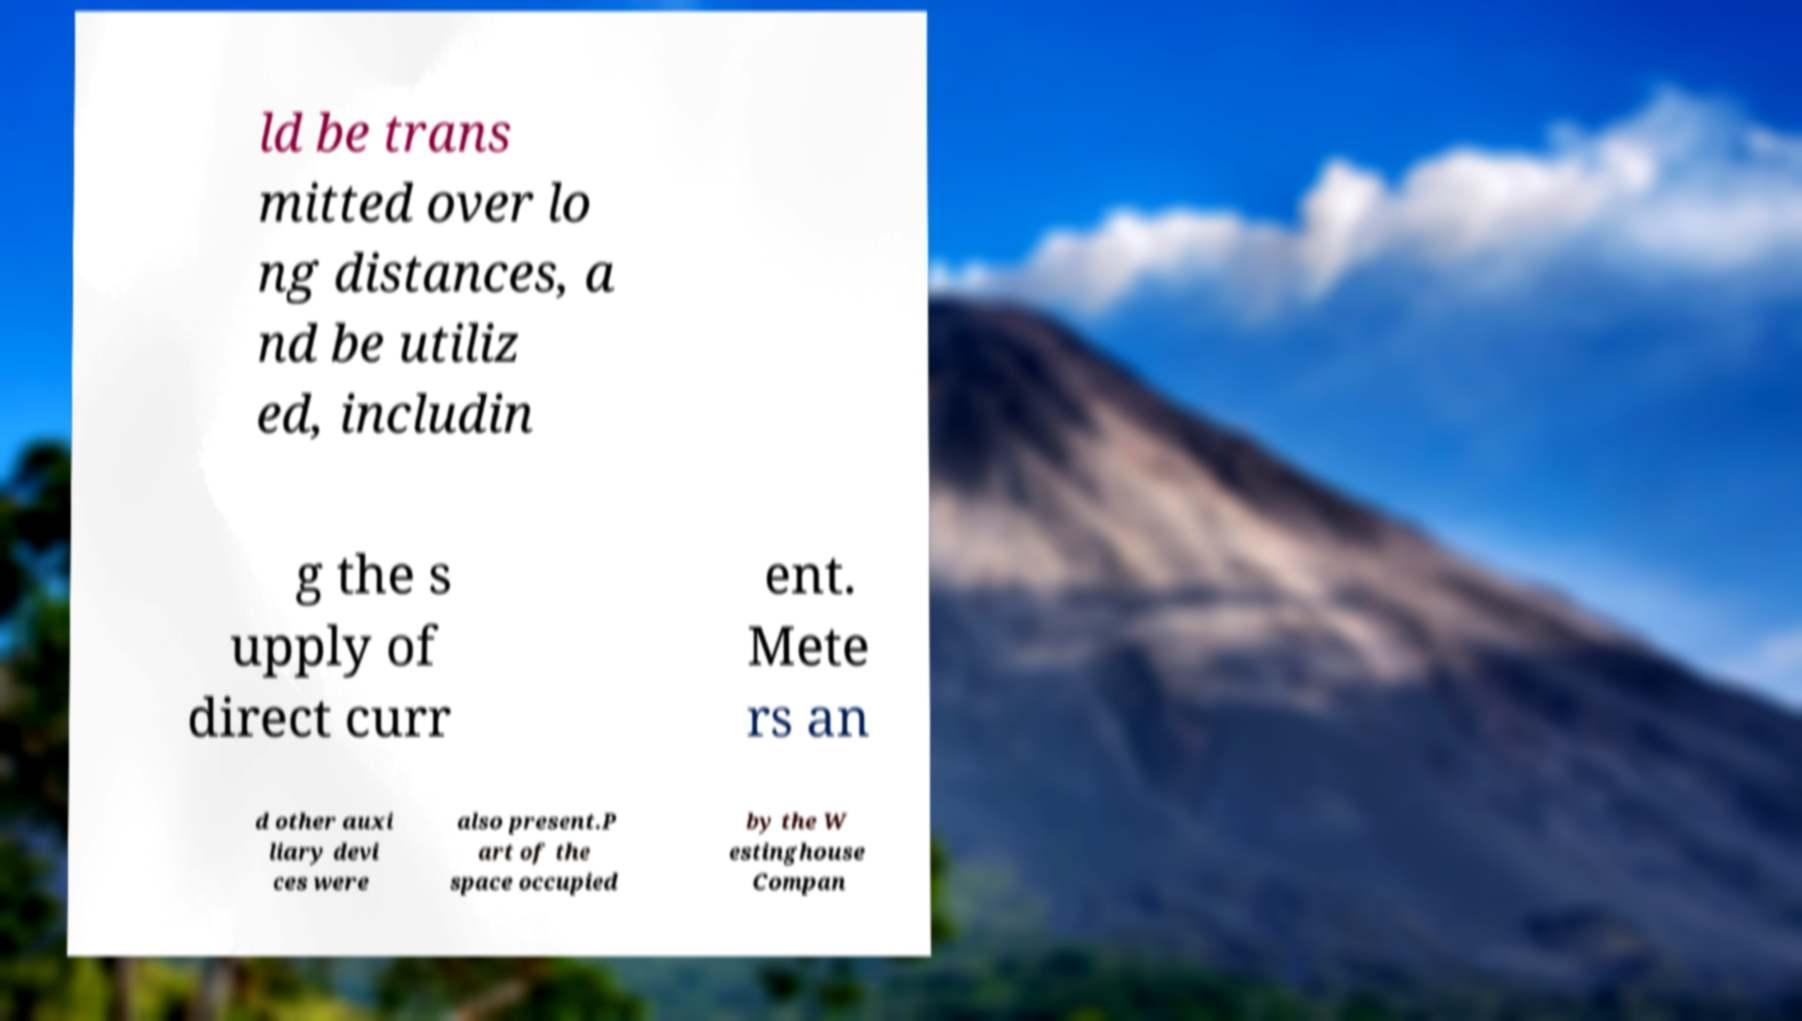Could you extract and type out the text from this image? ld be trans mitted over lo ng distances, a nd be utiliz ed, includin g the s upply of direct curr ent. Mete rs an d other auxi liary devi ces were also present.P art of the space occupied by the W estinghouse Compan 